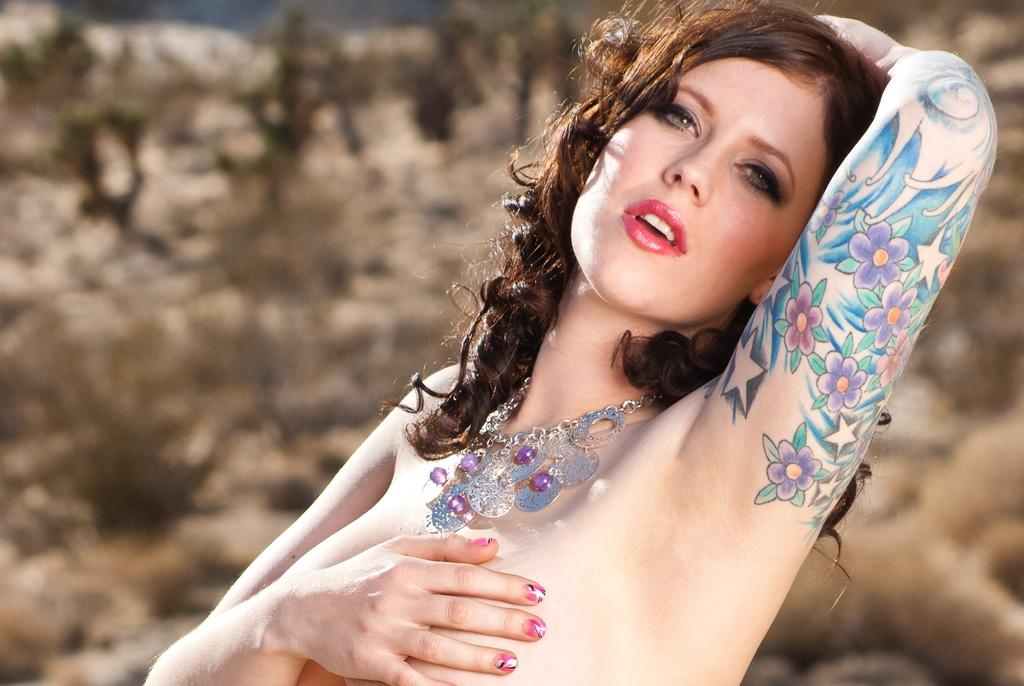What is the main subject of the image? There is a person in the image. What can be observed about the person's appearance? The person is wearing jewelry and has a colorful tattoo on their hand. Can you describe the background of the image? The background of the image is blurred. What is the person's annual income in the image? There is no information about the person's income in the image. What country is the person from in the image? There is no information about the person's country of origin in the image. 